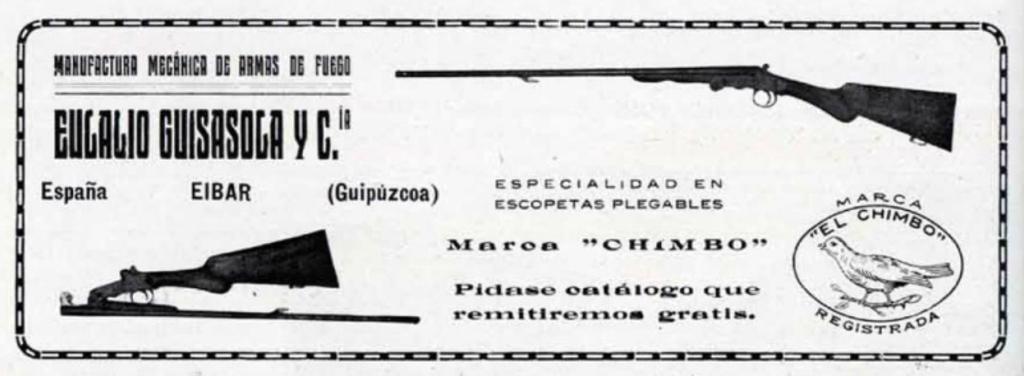Describe this image in one or two sentences. In this picture there are two guns and there is something written below and above it. 